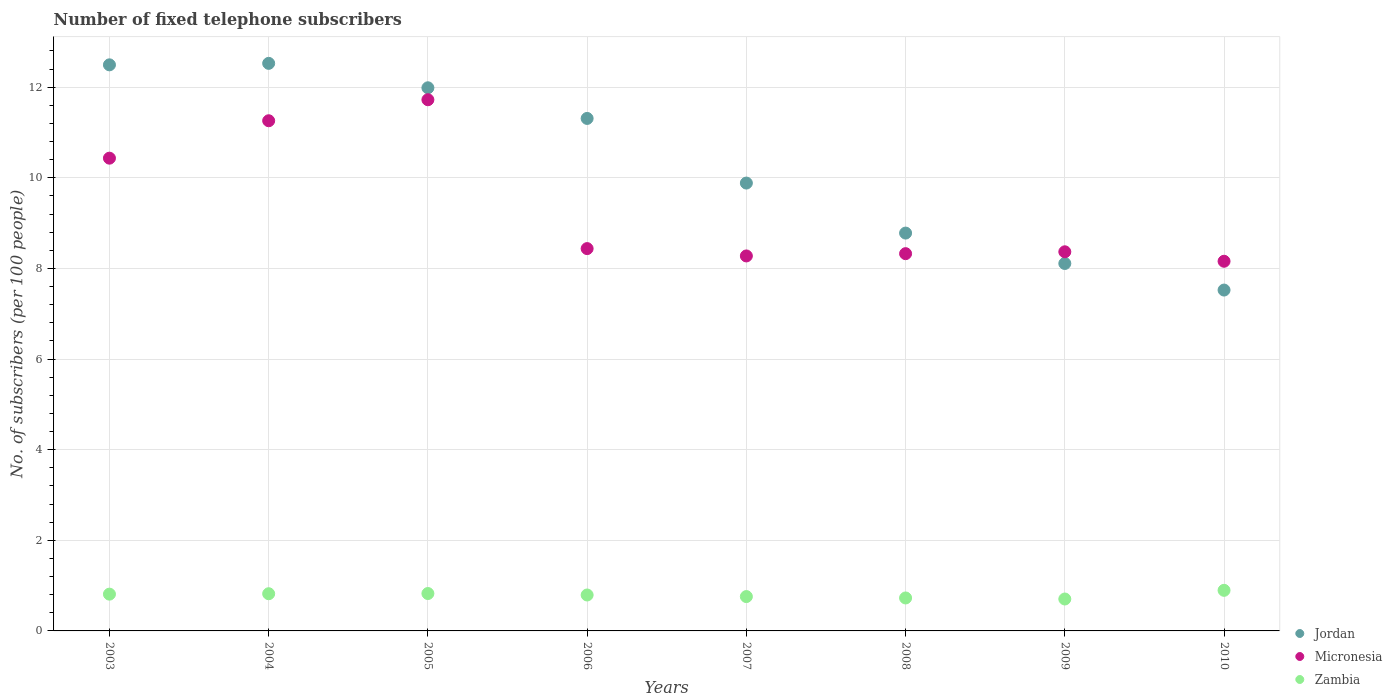What is the number of fixed telephone subscribers in Jordan in 2010?
Provide a short and direct response. 7.52. Across all years, what is the maximum number of fixed telephone subscribers in Micronesia?
Offer a terse response. 11.72. Across all years, what is the minimum number of fixed telephone subscribers in Micronesia?
Your response must be concise. 8.16. In which year was the number of fixed telephone subscribers in Jordan maximum?
Offer a very short reply. 2004. In which year was the number of fixed telephone subscribers in Zambia minimum?
Make the answer very short. 2009. What is the total number of fixed telephone subscribers in Micronesia in the graph?
Keep it short and to the point. 74.98. What is the difference between the number of fixed telephone subscribers in Micronesia in 2004 and that in 2008?
Offer a very short reply. 2.93. What is the difference between the number of fixed telephone subscribers in Jordan in 2007 and the number of fixed telephone subscribers in Zambia in 2008?
Provide a short and direct response. 9.16. What is the average number of fixed telephone subscribers in Jordan per year?
Offer a terse response. 10.33. In the year 2006, what is the difference between the number of fixed telephone subscribers in Jordan and number of fixed telephone subscribers in Zambia?
Your response must be concise. 10.52. In how many years, is the number of fixed telephone subscribers in Zambia greater than 6.8?
Give a very brief answer. 0. What is the ratio of the number of fixed telephone subscribers in Jordan in 2005 to that in 2009?
Offer a very short reply. 1.48. Is the number of fixed telephone subscribers in Jordan in 2003 less than that in 2005?
Give a very brief answer. No. What is the difference between the highest and the second highest number of fixed telephone subscribers in Jordan?
Ensure brevity in your answer.  0.03. What is the difference between the highest and the lowest number of fixed telephone subscribers in Micronesia?
Provide a short and direct response. 3.56. Is the sum of the number of fixed telephone subscribers in Jordan in 2007 and 2008 greater than the maximum number of fixed telephone subscribers in Zambia across all years?
Offer a very short reply. Yes. Is it the case that in every year, the sum of the number of fixed telephone subscribers in Micronesia and number of fixed telephone subscribers in Jordan  is greater than the number of fixed telephone subscribers in Zambia?
Provide a short and direct response. Yes. Is the number of fixed telephone subscribers in Jordan strictly greater than the number of fixed telephone subscribers in Zambia over the years?
Make the answer very short. Yes. Is the number of fixed telephone subscribers in Micronesia strictly less than the number of fixed telephone subscribers in Zambia over the years?
Make the answer very short. No. How many years are there in the graph?
Offer a very short reply. 8. Are the values on the major ticks of Y-axis written in scientific E-notation?
Offer a terse response. No. How many legend labels are there?
Your response must be concise. 3. How are the legend labels stacked?
Give a very brief answer. Vertical. What is the title of the graph?
Offer a terse response. Number of fixed telephone subscribers. What is the label or title of the X-axis?
Make the answer very short. Years. What is the label or title of the Y-axis?
Offer a very short reply. No. of subscribers (per 100 people). What is the No. of subscribers (per 100 people) in Jordan in 2003?
Your answer should be very brief. 12.49. What is the No. of subscribers (per 100 people) of Micronesia in 2003?
Provide a succinct answer. 10.43. What is the No. of subscribers (per 100 people) of Zambia in 2003?
Give a very brief answer. 0.81. What is the No. of subscribers (per 100 people) in Jordan in 2004?
Ensure brevity in your answer.  12.53. What is the No. of subscribers (per 100 people) of Micronesia in 2004?
Give a very brief answer. 11.26. What is the No. of subscribers (per 100 people) in Zambia in 2004?
Ensure brevity in your answer.  0.82. What is the No. of subscribers (per 100 people) of Jordan in 2005?
Your answer should be very brief. 11.99. What is the No. of subscribers (per 100 people) in Micronesia in 2005?
Your response must be concise. 11.72. What is the No. of subscribers (per 100 people) in Zambia in 2005?
Keep it short and to the point. 0.83. What is the No. of subscribers (per 100 people) in Jordan in 2006?
Your answer should be very brief. 11.31. What is the No. of subscribers (per 100 people) of Micronesia in 2006?
Your answer should be compact. 8.44. What is the No. of subscribers (per 100 people) in Zambia in 2006?
Offer a very short reply. 0.79. What is the No. of subscribers (per 100 people) of Jordan in 2007?
Provide a succinct answer. 9.88. What is the No. of subscribers (per 100 people) in Micronesia in 2007?
Provide a succinct answer. 8.28. What is the No. of subscribers (per 100 people) in Zambia in 2007?
Keep it short and to the point. 0.76. What is the No. of subscribers (per 100 people) of Jordan in 2008?
Your answer should be very brief. 8.78. What is the No. of subscribers (per 100 people) in Micronesia in 2008?
Your answer should be compact. 8.33. What is the No. of subscribers (per 100 people) in Zambia in 2008?
Ensure brevity in your answer.  0.73. What is the No. of subscribers (per 100 people) in Jordan in 2009?
Offer a terse response. 8.11. What is the No. of subscribers (per 100 people) of Micronesia in 2009?
Your response must be concise. 8.37. What is the No. of subscribers (per 100 people) of Zambia in 2009?
Keep it short and to the point. 0.7. What is the No. of subscribers (per 100 people) of Jordan in 2010?
Offer a terse response. 7.52. What is the No. of subscribers (per 100 people) of Micronesia in 2010?
Give a very brief answer. 8.16. What is the No. of subscribers (per 100 people) of Zambia in 2010?
Offer a very short reply. 0.9. Across all years, what is the maximum No. of subscribers (per 100 people) of Jordan?
Your response must be concise. 12.53. Across all years, what is the maximum No. of subscribers (per 100 people) in Micronesia?
Provide a short and direct response. 11.72. Across all years, what is the maximum No. of subscribers (per 100 people) of Zambia?
Your response must be concise. 0.9. Across all years, what is the minimum No. of subscribers (per 100 people) of Jordan?
Your answer should be very brief. 7.52. Across all years, what is the minimum No. of subscribers (per 100 people) in Micronesia?
Ensure brevity in your answer.  8.16. Across all years, what is the minimum No. of subscribers (per 100 people) of Zambia?
Make the answer very short. 0.7. What is the total No. of subscribers (per 100 people) in Jordan in the graph?
Your answer should be very brief. 82.61. What is the total No. of subscribers (per 100 people) of Micronesia in the graph?
Provide a succinct answer. 74.98. What is the total No. of subscribers (per 100 people) of Zambia in the graph?
Ensure brevity in your answer.  6.34. What is the difference between the No. of subscribers (per 100 people) in Jordan in 2003 and that in 2004?
Keep it short and to the point. -0.03. What is the difference between the No. of subscribers (per 100 people) in Micronesia in 2003 and that in 2004?
Offer a very short reply. -0.83. What is the difference between the No. of subscribers (per 100 people) of Zambia in 2003 and that in 2004?
Your answer should be compact. -0.01. What is the difference between the No. of subscribers (per 100 people) of Jordan in 2003 and that in 2005?
Give a very brief answer. 0.51. What is the difference between the No. of subscribers (per 100 people) in Micronesia in 2003 and that in 2005?
Your answer should be compact. -1.29. What is the difference between the No. of subscribers (per 100 people) of Zambia in 2003 and that in 2005?
Ensure brevity in your answer.  -0.01. What is the difference between the No. of subscribers (per 100 people) in Jordan in 2003 and that in 2006?
Offer a terse response. 1.18. What is the difference between the No. of subscribers (per 100 people) in Micronesia in 2003 and that in 2006?
Offer a very short reply. 2. What is the difference between the No. of subscribers (per 100 people) of Zambia in 2003 and that in 2006?
Your answer should be compact. 0.02. What is the difference between the No. of subscribers (per 100 people) in Jordan in 2003 and that in 2007?
Your response must be concise. 2.61. What is the difference between the No. of subscribers (per 100 people) in Micronesia in 2003 and that in 2007?
Offer a very short reply. 2.16. What is the difference between the No. of subscribers (per 100 people) in Zambia in 2003 and that in 2007?
Your answer should be compact. 0.05. What is the difference between the No. of subscribers (per 100 people) of Jordan in 2003 and that in 2008?
Provide a succinct answer. 3.71. What is the difference between the No. of subscribers (per 100 people) in Micronesia in 2003 and that in 2008?
Make the answer very short. 2.11. What is the difference between the No. of subscribers (per 100 people) in Zambia in 2003 and that in 2008?
Give a very brief answer. 0.08. What is the difference between the No. of subscribers (per 100 people) in Jordan in 2003 and that in 2009?
Offer a very short reply. 4.38. What is the difference between the No. of subscribers (per 100 people) of Micronesia in 2003 and that in 2009?
Your answer should be compact. 2.07. What is the difference between the No. of subscribers (per 100 people) of Zambia in 2003 and that in 2009?
Your answer should be compact. 0.11. What is the difference between the No. of subscribers (per 100 people) of Jordan in 2003 and that in 2010?
Offer a terse response. 4.97. What is the difference between the No. of subscribers (per 100 people) of Micronesia in 2003 and that in 2010?
Offer a very short reply. 2.28. What is the difference between the No. of subscribers (per 100 people) of Zambia in 2003 and that in 2010?
Provide a short and direct response. -0.08. What is the difference between the No. of subscribers (per 100 people) of Jordan in 2004 and that in 2005?
Your response must be concise. 0.54. What is the difference between the No. of subscribers (per 100 people) in Micronesia in 2004 and that in 2005?
Give a very brief answer. -0.46. What is the difference between the No. of subscribers (per 100 people) in Zambia in 2004 and that in 2005?
Provide a short and direct response. -0. What is the difference between the No. of subscribers (per 100 people) of Jordan in 2004 and that in 2006?
Offer a very short reply. 1.22. What is the difference between the No. of subscribers (per 100 people) in Micronesia in 2004 and that in 2006?
Offer a very short reply. 2.82. What is the difference between the No. of subscribers (per 100 people) of Zambia in 2004 and that in 2006?
Provide a short and direct response. 0.03. What is the difference between the No. of subscribers (per 100 people) in Jordan in 2004 and that in 2007?
Offer a terse response. 2.64. What is the difference between the No. of subscribers (per 100 people) in Micronesia in 2004 and that in 2007?
Ensure brevity in your answer.  2.98. What is the difference between the No. of subscribers (per 100 people) in Zambia in 2004 and that in 2007?
Offer a very short reply. 0.06. What is the difference between the No. of subscribers (per 100 people) in Jordan in 2004 and that in 2008?
Your answer should be compact. 3.75. What is the difference between the No. of subscribers (per 100 people) of Micronesia in 2004 and that in 2008?
Provide a succinct answer. 2.93. What is the difference between the No. of subscribers (per 100 people) of Zambia in 2004 and that in 2008?
Your answer should be compact. 0.09. What is the difference between the No. of subscribers (per 100 people) in Jordan in 2004 and that in 2009?
Your answer should be compact. 4.42. What is the difference between the No. of subscribers (per 100 people) of Micronesia in 2004 and that in 2009?
Provide a short and direct response. 2.89. What is the difference between the No. of subscribers (per 100 people) of Zambia in 2004 and that in 2009?
Give a very brief answer. 0.12. What is the difference between the No. of subscribers (per 100 people) of Jordan in 2004 and that in 2010?
Make the answer very short. 5. What is the difference between the No. of subscribers (per 100 people) of Micronesia in 2004 and that in 2010?
Offer a very short reply. 3.1. What is the difference between the No. of subscribers (per 100 people) in Zambia in 2004 and that in 2010?
Keep it short and to the point. -0.07. What is the difference between the No. of subscribers (per 100 people) of Jordan in 2005 and that in 2006?
Your answer should be very brief. 0.68. What is the difference between the No. of subscribers (per 100 people) in Micronesia in 2005 and that in 2006?
Provide a succinct answer. 3.29. What is the difference between the No. of subscribers (per 100 people) of Zambia in 2005 and that in 2006?
Keep it short and to the point. 0.03. What is the difference between the No. of subscribers (per 100 people) in Jordan in 2005 and that in 2007?
Your response must be concise. 2.1. What is the difference between the No. of subscribers (per 100 people) in Micronesia in 2005 and that in 2007?
Make the answer very short. 3.45. What is the difference between the No. of subscribers (per 100 people) of Zambia in 2005 and that in 2007?
Provide a short and direct response. 0.07. What is the difference between the No. of subscribers (per 100 people) in Jordan in 2005 and that in 2008?
Keep it short and to the point. 3.21. What is the difference between the No. of subscribers (per 100 people) of Micronesia in 2005 and that in 2008?
Your answer should be compact. 3.4. What is the difference between the No. of subscribers (per 100 people) in Zambia in 2005 and that in 2008?
Your answer should be compact. 0.1. What is the difference between the No. of subscribers (per 100 people) of Jordan in 2005 and that in 2009?
Offer a terse response. 3.88. What is the difference between the No. of subscribers (per 100 people) in Micronesia in 2005 and that in 2009?
Offer a terse response. 3.36. What is the difference between the No. of subscribers (per 100 people) of Zambia in 2005 and that in 2009?
Provide a short and direct response. 0.12. What is the difference between the No. of subscribers (per 100 people) in Jordan in 2005 and that in 2010?
Offer a very short reply. 4.46. What is the difference between the No. of subscribers (per 100 people) of Micronesia in 2005 and that in 2010?
Offer a terse response. 3.56. What is the difference between the No. of subscribers (per 100 people) of Zambia in 2005 and that in 2010?
Offer a very short reply. -0.07. What is the difference between the No. of subscribers (per 100 people) of Jordan in 2006 and that in 2007?
Offer a very short reply. 1.43. What is the difference between the No. of subscribers (per 100 people) of Micronesia in 2006 and that in 2007?
Ensure brevity in your answer.  0.16. What is the difference between the No. of subscribers (per 100 people) of Zambia in 2006 and that in 2007?
Your answer should be compact. 0.04. What is the difference between the No. of subscribers (per 100 people) of Jordan in 2006 and that in 2008?
Make the answer very short. 2.53. What is the difference between the No. of subscribers (per 100 people) of Micronesia in 2006 and that in 2008?
Your answer should be very brief. 0.11. What is the difference between the No. of subscribers (per 100 people) in Zambia in 2006 and that in 2008?
Your answer should be compact. 0.07. What is the difference between the No. of subscribers (per 100 people) in Jordan in 2006 and that in 2009?
Your answer should be very brief. 3.2. What is the difference between the No. of subscribers (per 100 people) of Micronesia in 2006 and that in 2009?
Your response must be concise. 0.07. What is the difference between the No. of subscribers (per 100 people) of Zambia in 2006 and that in 2009?
Your answer should be compact. 0.09. What is the difference between the No. of subscribers (per 100 people) in Jordan in 2006 and that in 2010?
Offer a terse response. 3.79. What is the difference between the No. of subscribers (per 100 people) of Micronesia in 2006 and that in 2010?
Give a very brief answer. 0.28. What is the difference between the No. of subscribers (per 100 people) in Zambia in 2006 and that in 2010?
Keep it short and to the point. -0.1. What is the difference between the No. of subscribers (per 100 people) in Jordan in 2007 and that in 2008?
Your response must be concise. 1.1. What is the difference between the No. of subscribers (per 100 people) in Micronesia in 2007 and that in 2008?
Your answer should be very brief. -0.05. What is the difference between the No. of subscribers (per 100 people) in Zambia in 2007 and that in 2008?
Give a very brief answer. 0.03. What is the difference between the No. of subscribers (per 100 people) in Jordan in 2007 and that in 2009?
Offer a terse response. 1.77. What is the difference between the No. of subscribers (per 100 people) in Micronesia in 2007 and that in 2009?
Your answer should be very brief. -0.09. What is the difference between the No. of subscribers (per 100 people) of Zambia in 2007 and that in 2009?
Make the answer very short. 0.05. What is the difference between the No. of subscribers (per 100 people) in Jordan in 2007 and that in 2010?
Your answer should be compact. 2.36. What is the difference between the No. of subscribers (per 100 people) in Micronesia in 2007 and that in 2010?
Give a very brief answer. 0.12. What is the difference between the No. of subscribers (per 100 people) in Zambia in 2007 and that in 2010?
Ensure brevity in your answer.  -0.14. What is the difference between the No. of subscribers (per 100 people) in Jordan in 2008 and that in 2009?
Keep it short and to the point. 0.67. What is the difference between the No. of subscribers (per 100 people) of Micronesia in 2008 and that in 2009?
Keep it short and to the point. -0.04. What is the difference between the No. of subscribers (per 100 people) of Zambia in 2008 and that in 2009?
Provide a succinct answer. 0.02. What is the difference between the No. of subscribers (per 100 people) of Jordan in 2008 and that in 2010?
Give a very brief answer. 1.26. What is the difference between the No. of subscribers (per 100 people) of Micronesia in 2008 and that in 2010?
Make the answer very short. 0.17. What is the difference between the No. of subscribers (per 100 people) in Zambia in 2008 and that in 2010?
Offer a very short reply. -0.17. What is the difference between the No. of subscribers (per 100 people) of Jordan in 2009 and that in 2010?
Make the answer very short. 0.59. What is the difference between the No. of subscribers (per 100 people) in Micronesia in 2009 and that in 2010?
Make the answer very short. 0.21. What is the difference between the No. of subscribers (per 100 people) of Zambia in 2009 and that in 2010?
Ensure brevity in your answer.  -0.19. What is the difference between the No. of subscribers (per 100 people) of Jordan in 2003 and the No. of subscribers (per 100 people) of Micronesia in 2004?
Offer a terse response. 1.23. What is the difference between the No. of subscribers (per 100 people) of Jordan in 2003 and the No. of subscribers (per 100 people) of Zambia in 2004?
Your answer should be very brief. 11.67. What is the difference between the No. of subscribers (per 100 people) in Micronesia in 2003 and the No. of subscribers (per 100 people) in Zambia in 2004?
Your answer should be very brief. 9.61. What is the difference between the No. of subscribers (per 100 people) in Jordan in 2003 and the No. of subscribers (per 100 people) in Micronesia in 2005?
Make the answer very short. 0.77. What is the difference between the No. of subscribers (per 100 people) of Jordan in 2003 and the No. of subscribers (per 100 people) of Zambia in 2005?
Keep it short and to the point. 11.67. What is the difference between the No. of subscribers (per 100 people) in Micronesia in 2003 and the No. of subscribers (per 100 people) in Zambia in 2005?
Provide a short and direct response. 9.61. What is the difference between the No. of subscribers (per 100 people) of Jordan in 2003 and the No. of subscribers (per 100 people) of Micronesia in 2006?
Offer a very short reply. 4.06. What is the difference between the No. of subscribers (per 100 people) in Jordan in 2003 and the No. of subscribers (per 100 people) in Zambia in 2006?
Offer a very short reply. 11.7. What is the difference between the No. of subscribers (per 100 people) in Micronesia in 2003 and the No. of subscribers (per 100 people) in Zambia in 2006?
Your answer should be compact. 9.64. What is the difference between the No. of subscribers (per 100 people) of Jordan in 2003 and the No. of subscribers (per 100 people) of Micronesia in 2007?
Your response must be concise. 4.22. What is the difference between the No. of subscribers (per 100 people) of Jordan in 2003 and the No. of subscribers (per 100 people) of Zambia in 2007?
Offer a terse response. 11.73. What is the difference between the No. of subscribers (per 100 people) in Micronesia in 2003 and the No. of subscribers (per 100 people) in Zambia in 2007?
Give a very brief answer. 9.67. What is the difference between the No. of subscribers (per 100 people) in Jordan in 2003 and the No. of subscribers (per 100 people) in Micronesia in 2008?
Ensure brevity in your answer.  4.17. What is the difference between the No. of subscribers (per 100 people) in Jordan in 2003 and the No. of subscribers (per 100 people) in Zambia in 2008?
Make the answer very short. 11.77. What is the difference between the No. of subscribers (per 100 people) in Micronesia in 2003 and the No. of subscribers (per 100 people) in Zambia in 2008?
Offer a very short reply. 9.71. What is the difference between the No. of subscribers (per 100 people) in Jordan in 2003 and the No. of subscribers (per 100 people) in Micronesia in 2009?
Your answer should be compact. 4.13. What is the difference between the No. of subscribers (per 100 people) of Jordan in 2003 and the No. of subscribers (per 100 people) of Zambia in 2009?
Make the answer very short. 11.79. What is the difference between the No. of subscribers (per 100 people) in Micronesia in 2003 and the No. of subscribers (per 100 people) in Zambia in 2009?
Ensure brevity in your answer.  9.73. What is the difference between the No. of subscribers (per 100 people) of Jordan in 2003 and the No. of subscribers (per 100 people) of Micronesia in 2010?
Provide a succinct answer. 4.33. What is the difference between the No. of subscribers (per 100 people) of Jordan in 2003 and the No. of subscribers (per 100 people) of Zambia in 2010?
Provide a succinct answer. 11.6. What is the difference between the No. of subscribers (per 100 people) of Micronesia in 2003 and the No. of subscribers (per 100 people) of Zambia in 2010?
Your answer should be very brief. 9.54. What is the difference between the No. of subscribers (per 100 people) in Jordan in 2004 and the No. of subscribers (per 100 people) in Micronesia in 2005?
Keep it short and to the point. 0.8. What is the difference between the No. of subscribers (per 100 people) in Micronesia in 2004 and the No. of subscribers (per 100 people) in Zambia in 2005?
Provide a succinct answer. 10.43. What is the difference between the No. of subscribers (per 100 people) of Jordan in 2004 and the No. of subscribers (per 100 people) of Micronesia in 2006?
Provide a short and direct response. 4.09. What is the difference between the No. of subscribers (per 100 people) in Jordan in 2004 and the No. of subscribers (per 100 people) in Zambia in 2006?
Make the answer very short. 11.73. What is the difference between the No. of subscribers (per 100 people) in Micronesia in 2004 and the No. of subscribers (per 100 people) in Zambia in 2006?
Give a very brief answer. 10.47. What is the difference between the No. of subscribers (per 100 people) of Jordan in 2004 and the No. of subscribers (per 100 people) of Micronesia in 2007?
Your answer should be compact. 4.25. What is the difference between the No. of subscribers (per 100 people) of Jordan in 2004 and the No. of subscribers (per 100 people) of Zambia in 2007?
Give a very brief answer. 11.77. What is the difference between the No. of subscribers (per 100 people) in Micronesia in 2004 and the No. of subscribers (per 100 people) in Zambia in 2007?
Your answer should be compact. 10.5. What is the difference between the No. of subscribers (per 100 people) in Jordan in 2004 and the No. of subscribers (per 100 people) in Micronesia in 2008?
Offer a very short reply. 4.2. What is the difference between the No. of subscribers (per 100 people) of Jordan in 2004 and the No. of subscribers (per 100 people) of Zambia in 2008?
Give a very brief answer. 11.8. What is the difference between the No. of subscribers (per 100 people) in Micronesia in 2004 and the No. of subscribers (per 100 people) in Zambia in 2008?
Offer a terse response. 10.53. What is the difference between the No. of subscribers (per 100 people) in Jordan in 2004 and the No. of subscribers (per 100 people) in Micronesia in 2009?
Provide a short and direct response. 4.16. What is the difference between the No. of subscribers (per 100 people) in Jordan in 2004 and the No. of subscribers (per 100 people) in Zambia in 2009?
Provide a succinct answer. 11.82. What is the difference between the No. of subscribers (per 100 people) in Micronesia in 2004 and the No. of subscribers (per 100 people) in Zambia in 2009?
Make the answer very short. 10.55. What is the difference between the No. of subscribers (per 100 people) of Jordan in 2004 and the No. of subscribers (per 100 people) of Micronesia in 2010?
Offer a very short reply. 4.37. What is the difference between the No. of subscribers (per 100 people) of Jordan in 2004 and the No. of subscribers (per 100 people) of Zambia in 2010?
Offer a very short reply. 11.63. What is the difference between the No. of subscribers (per 100 people) in Micronesia in 2004 and the No. of subscribers (per 100 people) in Zambia in 2010?
Your response must be concise. 10.36. What is the difference between the No. of subscribers (per 100 people) in Jordan in 2005 and the No. of subscribers (per 100 people) in Micronesia in 2006?
Keep it short and to the point. 3.55. What is the difference between the No. of subscribers (per 100 people) in Jordan in 2005 and the No. of subscribers (per 100 people) in Zambia in 2006?
Provide a succinct answer. 11.19. What is the difference between the No. of subscribers (per 100 people) in Micronesia in 2005 and the No. of subscribers (per 100 people) in Zambia in 2006?
Provide a short and direct response. 10.93. What is the difference between the No. of subscribers (per 100 people) of Jordan in 2005 and the No. of subscribers (per 100 people) of Micronesia in 2007?
Give a very brief answer. 3.71. What is the difference between the No. of subscribers (per 100 people) in Jordan in 2005 and the No. of subscribers (per 100 people) in Zambia in 2007?
Offer a very short reply. 11.23. What is the difference between the No. of subscribers (per 100 people) of Micronesia in 2005 and the No. of subscribers (per 100 people) of Zambia in 2007?
Give a very brief answer. 10.96. What is the difference between the No. of subscribers (per 100 people) in Jordan in 2005 and the No. of subscribers (per 100 people) in Micronesia in 2008?
Offer a terse response. 3.66. What is the difference between the No. of subscribers (per 100 people) of Jordan in 2005 and the No. of subscribers (per 100 people) of Zambia in 2008?
Ensure brevity in your answer.  11.26. What is the difference between the No. of subscribers (per 100 people) in Micronesia in 2005 and the No. of subscribers (per 100 people) in Zambia in 2008?
Provide a short and direct response. 11. What is the difference between the No. of subscribers (per 100 people) in Jordan in 2005 and the No. of subscribers (per 100 people) in Micronesia in 2009?
Keep it short and to the point. 3.62. What is the difference between the No. of subscribers (per 100 people) of Jordan in 2005 and the No. of subscribers (per 100 people) of Zambia in 2009?
Provide a short and direct response. 11.28. What is the difference between the No. of subscribers (per 100 people) in Micronesia in 2005 and the No. of subscribers (per 100 people) in Zambia in 2009?
Offer a terse response. 11.02. What is the difference between the No. of subscribers (per 100 people) in Jordan in 2005 and the No. of subscribers (per 100 people) in Micronesia in 2010?
Your answer should be compact. 3.83. What is the difference between the No. of subscribers (per 100 people) in Jordan in 2005 and the No. of subscribers (per 100 people) in Zambia in 2010?
Offer a terse response. 11.09. What is the difference between the No. of subscribers (per 100 people) of Micronesia in 2005 and the No. of subscribers (per 100 people) of Zambia in 2010?
Offer a very short reply. 10.83. What is the difference between the No. of subscribers (per 100 people) of Jordan in 2006 and the No. of subscribers (per 100 people) of Micronesia in 2007?
Keep it short and to the point. 3.03. What is the difference between the No. of subscribers (per 100 people) in Jordan in 2006 and the No. of subscribers (per 100 people) in Zambia in 2007?
Ensure brevity in your answer.  10.55. What is the difference between the No. of subscribers (per 100 people) of Micronesia in 2006 and the No. of subscribers (per 100 people) of Zambia in 2007?
Give a very brief answer. 7.68. What is the difference between the No. of subscribers (per 100 people) in Jordan in 2006 and the No. of subscribers (per 100 people) in Micronesia in 2008?
Provide a short and direct response. 2.98. What is the difference between the No. of subscribers (per 100 people) of Jordan in 2006 and the No. of subscribers (per 100 people) of Zambia in 2008?
Make the answer very short. 10.58. What is the difference between the No. of subscribers (per 100 people) of Micronesia in 2006 and the No. of subscribers (per 100 people) of Zambia in 2008?
Give a very brief answer. 7.71. What is the difference between the No. of subscribers (per 100 people) of Jordan in 2006 and the No. of subscribers (per 100 people) of Micronesia in 2009?
Your answer should be compact. 2.94. What is the difference between the No. of subscribers (per 100 people) of Jordan in 2006 and the No. of subscribers (per 100 people) of Zambia in 2009?
Offer a very short reply. 10.61. What is the difference between the No. of subscribers (per 100 people) in Micronesia in 2006 and the No. of subscribers (per 100 people) in Zambia in 2009?
Offer a terse response. 7.73. What is the difference between the No. of subscribers (per 100 people) in Jordan in 2006 and the No. of subscribers (per 100 people) in Micronesia in 2010?
Give a very brief answer. 3.15. What is the difference between the No. of subscribers (per 100 people) in Jordan in 2006 and the No. of subscribers (per 100 people) in Zambia in 2010?
Offer a terse response. 10.41. What is the difference between the No. of subscribers (per 100 people) in Micronesia in 2006 and the No. of subscribers (per 100 people) in Zambia in 2010?
Your answer should be compact. 7.54. What is the difference between the No. of subscribers (per 100 people) in Jordan in 2007 and the No. of subscribers (per 100 people) in Micronesia in 2008?
Offer a terse response. 1.56. What is the difference between the No. of subscribers (per 100 people) of Jordan in 2007 and the No. of subscribers (per 100 people) of Zambia in 2008?
Provide a short and direct response. 9.16. What is the difference between the No. of subscribers (per 100 people) of Micronesia in 2007 and the No. of subscribers (per 100 people) of Zambia in 2008?
Provide a succinct answer. 7.55. What is the difference between the No. of subscribers (per 100 people) of Jordan in 2007 and the No. of subscribers (per 100 people) of Micronesia in 2009?
Make the answer very short. 1.52. What is the difference between the No. of subscribers (per 100 people) of Jordan in 2007 and the No. of subscribers (per 100 people) of Zambia in 2009?
Your response must be concise. 9.18. What is the difference between the No. of subscribers (per 100 people) in Micronesia in 2007 and the No. of subscribers (per 100 people) in Zambia in 2009?
Keep it short and to the point. 7.57. What is the difference between the No. of subscribers (per 100 people) of Jordan in 2007 and the No. of subscribers (per 100 people) of Micronesia in 2010?
Your answer should be very brief. 1.73. What is the difference between the No. of subscribers (per 100 people) of Jordan in 2007 and the No. of subscribers (per 100 people) of Zambia in 2010?
Offer a very short reply. 8.99. What is the difference between the No. of subscribers (per 100 people) of Micronesia in 2007 and the No. of subscribers (per 100 people) of Zambia in 2010?
Ensure brevity in your answer.  7.38. What is the difference between the No. of subscribers (per 100 people) of Jordan in 2008 and the No. of subscribers (per 100 people) of Micronesia in 2009?
Provide a short and direct response. 0.41. What is the difference between the No. of subscribers (per 100 people) of Jordan in 2008 and the No. of subscribers (per 100 people) of Zambia in 2009?
Provide a succinct answer. 8.08. What is the difference between the No. of subscribers (per 100 people) in Micronesia in 2008 and the No. of subscribers (per 100 people) in Zambia in 2009?
Offer a very short reply. 7.62. What is the difference between the No. of subscribers (per 100 people) of Jordan in 2008 and the No. of subscribers (per 100 people) of Micronesia in 2010?
Give a very brief answer. 0.62. What is the difference between the No. of subscribers (per 100 people) in Jordan in 2008 and the No. of subscribers (per 100 people) in Zambia in 2010?
Your response must be concise. 7.88. What is the difference between the No. of subscribers (per 100 people) of Micronesia in 2008 and the No. of subscribers (per 100 people) of Zambia in 2010?
Provide a short and direct response. 7.43. What is the difference between the No. of subscribers (per 100 people) in Jordan in 2009 and the No. of subscribers (per 100 people) in Micronesia in 2010?
Offer a very short reply. -0.05. What is the difference between the No. of subscribers (per 100 people) of Jordan in 2009 and the No. of subscribers (per 100 people) of Zambia in 2010?
Your answer should be compact. 7.21. What is the difference between the No. of subscribers (per 100 people) of Micronesia in 2009 and the No. of subscribers (per 100 people) of Zambia in 2010?
Keep it short and to the point. 7.47. What is the average No. of subscribers (per 100 people) in Jordan per year?
Keep it short and to the point. 10.33. What is the average No. of subscribers (per 100 people) in Micronesia per year?
Provide a short and direct response. 9.37. What is the average No. of subscribers (per 100 people) of Zambia per year?
Provide a succinct answer. 0.79. In the year 2003, what is the difference between the No. of subscribers (per 100 people) in Jordan and No. of subscribers (per 100 people) in Micronesia?
Your answer should be compact. 2.06. In the year 2003, what is the difference between the No. of subscribers (per 100 people) of Jordan and No. of subscribers (per 100 people) of Zambia?
Offer a very short reply. 11.68. In the year 2003, what is the difference between the No. of subscribers (per 100 people) of Micronesia and No. of subscribers (per 100 people) of Zambia?
Offer a very short reply. 9.62. In the year 2004, what is the difference between the No. of subscribers (per 100 people) of Jordan and No. of subscribers (per 100 people) of Micronesia?
Ensure brevity in your answer.  1.27. In the year 2004, what is the difference between the No. of subscribers (per 100 people) of Jordan and No. of subscribers (per 100 people) of Zambia?
Give a very brief answer. 11.7. In the year 2004, what is the difference between the No. of subscribers (per 100 people) of Micronesia and No. of subscribers (per 100 people) of Zambia?
Provide a short and direct response. 10.44. In the year 2005, what is the difference between the No. of subscribers (per 100 people) in Jordan and No. of subscribers (per 100 people) in Micronesia?
Offer a terse response. 0.26. In the year 2005, what is the difference between the No. of subscribers (per 100 people) in Jordan and No. of subscribers (per 100 people) in Zambia?
Provide a succinct answer. 11.16. In the year 2005, what is the difference between the No. of subscribers (per 100 people) of Micronesia and No. of subscribers (per 100 people) of Zambia?
Your response must be concise. 10.9. In the year 2006, what is the difference between the No. of subscribers (per 100 people) in Jordan and No. of subscribers (per 100 people) in Micronesia?
Give a very brief answer. 2.87. In the year 2006, what is the difference between the No. of subscribers (per 100 people) in Jordan and No. of subscribers (per 100 people) in Zambia?
Your answer should be very brief. 10.52. In the year 2006, what is the difference between the No. of subscribers (per 100 people) of Micronesia and No. of subscribers (per 100 people) of Zambia?
Offer a very short reply. 7.64. In the year 2007, what is the difference between the No. of subscribers (per 100 people) of Jordan and No. of subscribers (per 100 people) of Micronesia?
Make the answer very short. 1.61. In the year 2007, what is the difference between the No. of subscribers (per 100 people) of Jordan and No. of subscribers (per 100 people) of Zambia?
Offer a terse response. 9.13. In the year 2007, what is the difference between the No. of subscribers (per 100 people) in Micronesia and No. of subscribers (per 100 people) in Zambia?
Provide a succinct answer. 7.52. In the year 2008, what is the difference between the No. of subscribers (per 100 people) in Jordan and No. of subscribers (per 100 people) in Micronesia?
Your answer should be very brief. 0.45. In the year 2008, what is the difference between the No. of subscribers (per 100 people) of Jordan and No. of subscribers (per 100 people) of Zambia?
Give a very brief answer. 8.05. In the year 2008, what is the difference between the No. of subscribers (per 100 people) in Micronesia and No. of subscribers (per 100 people) in Zambia?
Give a very brief answer. 7.6. In the year 2009, what is the difference between the No. of subscribers (per 100 people) of Jordan and No. of subscribers (per 100 people) of Micronesia?
Provide a short and direct response. -0.26. In the year 2009, what is the difference between the No. of subscribers (per 100 people) of Jordan and No. of subscribers (per 100 people) of Zambia?
Your answer should be compact. 7.4. In the year 2009, what is the difference between the No. of subscribers (per 100 people) of Micronesia and No. of subscribers (per 100 people) of Zambia?
Keep it short and to the point. 7.66. In the year 2010, what is the difference between the No. of subscribers (per 100 people) of Jordan and No. of subscribers (per 100 people) of Micronesia?
Your response must be concise. -0.64. In the year 2010, what is the difference between the No. of subscribers (per 100 people) in Jordan and No. of subscribers (per 100 people) in Zambia?
Your answer should be compact. 6.63. In the year 2010, what is the difference between the No. of subscribers (per 100 people) in Micronesia and No. of subscribers (per 100 people) in Zambia?
Your answer should be very brief. 7.26. What is the ratio of the No. of subscribers (per 100 people) of Jordan in 2003 to that in 2004?
Provide a short and direct response. 1. What is the ratio of the No. of subscribers (per 100 people) of Micronesia in 2003 to that in 2004?
Make the answer very short. 0.93. What is the ratio of the No. of subscribers (per 100 people) in Zambia in 2003 to that in 2004?
Offer a very short reply. 0.99. What is the ratio of the No. of subscribers (per 100 people) in Jordan in 2003 to that in 2005?
Offer a very short reply. 1.04. What is the ratio of the No. of subscribers (per 100 people) of Micronesia in 2003 to that in 2005?
Make the answer very short. 0.89. What is the ratio of the No. of subscribers (per 100 people) of Zambia in 2003 to that in 2005?
Give a very brief answer. 0.98. What is the ratio of the No. of subscribers (per 100 people) of Jordan in 2003 to that in 2006?
Your response must be concise. 1.1. What is the ratio of the No. of subscribers (per 100 people) of Micronesia in 2003 to that in 2006?
Your answer should be compact. 1.24. What is the ratio of the No. of subscribers (per 100 people) in Zambia in 2003 to that in 2006?
Your answer should be very brief. 1.02. What is the ratio of the No. of subscribers (per 100 people) in Jordan in 2003 to that in 2007?
Keep it short and to the point. 1.26. What is the ratio of the No. of subscribers (per 100 people) of Micronesia in 2003 to that in 2007?
Your response must be concise. 1.26. What is the ratio of the No. of subscribers (per 100 people) of Zambia in 2003 to that in 2007?
Offer a very short reply. 1.07. What is the ratio of the No. of subscribers (per 100 people) in Jordan in 2003 to that in 2008?
Make the answer very short. 1.42. What is the ratio of the No. of subscribers (per 100 people) of Micronesia in 2003 to that in 2008?
Give a very brief answer. 1.25. What is the ratio of the No. of subscribers (per 100 people) of Zambia in 2003 to that in 2008?
Make the answer very short. 1.12. What is the ratio of the No. of subscribers (per 100 people) of Jordan in 2003 to that in 2009?
Provide a succinct answer. 1.54. What is the ratio of the No. of subscribers (per 100 people) in Micronesia in 2003 to that in 2009?
Ensure brevity in your answer.  1.25. What is the ratio of the No. of subscribers (per 100 people) of Zambia in 2003 to that in 2009?
Offer a very short reply. 1.15. What is the ratio of the No. of subscribers (per 100 people) in Jordan in 2003 to that in 2010?
Ensure brevity in your answer.  1.66. What is the ratio of the No. of subscribers (per 100 people) in Micronesia in 2003 to that in 2010?
Offer a very short reply. 1.28. What is the ratio of the No. of subscribers (per 100 people) in Zambia in 2003 to that in 2010?
Make the answer very short. 0.91. What is the ratio of the No. of subscribers (per 100 people) in Jordan in 2004 to that in 2005?
Offer a terse response. 1.04. What is the ratio of the No. of subscribers (per 100 people) of Micronesia in 2004 to that in 2005?
Offer a terse response. 0.96. What is the ratio of the No. of subscribers (per 100 people) in Jordan in 2004 to that in 2006?
Offer a terse response. 1.11. What is the ratio of the No. of subscribers (per 100 people) of Micronesia in 2004 to that in 2006?
Make the answer very short. 1.33. What is the ratio of the No. of subscribers (per 100 people) of Zambia in 2004 to that in 2006?
Your answer should be compact. 1.03. What is the ratio of the No. of subscribers (per 100 people) in Jordan in 2004 to that in 2007?
Your response must be concise. 1.27. What is the ratio of the No. of subscribers (per 100 people) in Micronesia in 2004 to that in 2007?
Offer a very short reply. 1.36. What is the ratio of the No. of subscribers (per 100 people) in Zambia in 2004 to that in 2007?
Make the answer very short. 1.08. What is the ratio of the No. of subscribers (per 100 people) in Jordan in 2004 to that in 2008?
Make the answer very short. 1.43. What is the ratio of the No. of subscribers (per 100 people) of Micronesia in 2004 to that in 2008?
Your answer should be very brief. 1.35. What is the ratio of the No. of subscribers (per 100 people) of Zambia in 2004 to that in 2008?
Your answer should be very brief. 1.13. What is the ratio of the No. of subscribers (per 100 people) in Jordan in 2004 to that in 2009?
Ensure brevity in your answer.  1.54. What is the ratio of the No. of subscribers (per 100 people) of Micronesia in 2004 to that in 2009?
Ensure brevity in your answer.  1.35. What is the ratio of the No. of subscribers (per 100 people) in Zambia in 2004 to that in 2009?
Your response must be concise. 1.17. What is the ratio of the No. of subscribers (per 100 people) in Jordan in 2004 to that in 2010?
Give a very brief answer. 1.67. What is the ratio of the No. of subscribers (per 100 people) of Micronesia in 2004 to that in 2010?
Offer a terse response. 1.38. What is the ratio of the No. of subscribers (per 100 people) of Zambia in 2004 to that in 2010?
Ensure brevity in your answer.  0.92. What is the ratio of the No. of subscribers (per 100 people) in Jordan in 2005 to that in 2006?
Your answer should be very brief. 1.06. What is the ratio of the No. of subscribers (per 100 people) of Micronesia in 2005 to that in 2006?
Your answer should be very brief. 1.39. What is the ratio of the No. of subscribers (per 100 people) in Zambia in 2005 to that in 2006?
Your answer should be very brief. 1.04. What is the ratio of the No. of subscribers (per 100 people) in Jordan in 2005 to that in 2007?
Give a very brief answer. 1.21. What is the ratio of the No. of subscribers (per 100 people) of Micronesia in 2005 to that in 2007?
Your answer should be very brief. 1.42. What is the ratio of the No. of subscribers (per 100 people) of Zambia in 2005 to that in 2007?
Provide a succinct answer. 1.09. What is the ratio of the No. of subscribers (per 100 people) of Jordan in 2005 to that in 2008?
Provide a succinct answer. 1.37. What is the ratio of the No. of subscribers (per 100 people) of Micronesia in 2005 to that in 2008?
Offer a very short reply. 1.41. What is the ratio of the No. of subscribers (per 100 people) in Zambia in 2005 to that in 2008?
Provide a short and direct response. 1.13. What is the ratio of the No. of subscribers (per 100 people) in Jordan in 2005 to that in 2009?
Make the answer very short. 1.48. What is the ratio of the No. of subscribers (per 100 people) of Micronesia in 2005 to that in 2009?
Keep it short and to the point. 1.4. What is the ratio of the No. of subscribers (per 100 people) in Zambia in 2005 to that in 2009?
Keep it short and to the point. 1.17. What is the ratio of the No. of subscribers (per 100 people) of Jordan in 2005 to that in 2010?
Your answer should be very brief. 1.59. What is the ratio of the No. of subscribers (per 100 people) of Micronesia in 2005 to that in 2010?
Provide a short and direct response. 1.44. What is the ratio of the No. of subscribers (per 100 people) in Zambia in 2005 to that in 2010?
Offer a very short reply. 0.92. What is the ratio of the No. of subscribers (per 100 people) of Jordan in 2006 to that in 2007?
Your response must be concise. 1.14. What is the ratio of the No. of subscribers (per 100 people) in Micronesia in 2006 to that in 2007?
Ensure brevity in your answer.  1.02. What is the ratio of the No. of subscribers (per 100 people) of Zambia in 2006 to that in 2007?
Keep it short and to the point. 1.05. What is the ratio of the No. of subscribers (per 100 people) of Jordan in 2006 to that in 2008?
Provide a succinct answer. 1.29. What is the ratio of the No. of subscribers (per 100 people) of Micronesia in 2006 to that in 2008?
Provide a succinct answer. 1.01. What is the ratio of the No. of subscribers (per 100 people) of Zambia in 2006 to that in 2008?
Offer a terse response. 1.09. What is the ratio of the No. of subscribers (per 100 people) in Jordan in 2006 to that in 2009?
Your answer should be very brief. 1.39. What is the ratio of the No. of subscribers (per 100 people) of Micronesia in 2006 to that in 2009?
Keep it short and to the point. 1.01. What is the ratio of the No. of subscribers (per 100 people) in Zambia in 2006 to that in 2009?
Your answer should be compact. 1.13. What is the ratio of the No. of subscribers (per 100 people) in Jordan in 2006 to that in 2010?
Provide a succinct answer. 1.5. What is the ratio of the No. of subscribers (per 100 people) of Micronesia in 2006 to that in 2010?
Give a very brief answer. 1.03. What is the ratio of the No. of subscribers (per 100 people) of Zambia in 2006 to that in 2010?
Offer a very short reply. 0.89. What is the ratio of the No. of subscribers (per 100 people) of Jordan in 2007 to that in 2008?
Provide a succinct answer. 1.13. What is the ratio of the No. of subscribers (per 100 people) in Zambia in 2007 to that in 2008?
Ensure brevity in your answer.  1.04. What is the ratio of the No. of subscribers (per 100 people) in Jordan in 2007 to that in 2009?
Make the answer very short. 1.22. What is the ratio of the No. of subscribers (per 100 people) of Zambia in 2007 to that in 2009?
Your answer should be compact. 1.08. What is the ratio of the No. of subscribers (per 100 people) in Jordan in 2007 to that in 2010?
Give a very brief answer. 1.31. What is the ratio of the No. of subscribers (per 100 people) of Micronesia in 2007 to that in 2010?
Your answer should be very brief. 1.01. What is the ratio of the No. of subscribers (per 100 people) in Zambia in 2007 to that in 2010?
Your answer should be very brief. 0.85. What is the ratio of the No. of subscribers (per 100 people) in Jordan in 2008 to that in 2009?
Ensure brevity in your answer.  1.08. What is the ratio of the No. of subscribers (per 100 people) of Zambia in 2008 to that in 2009?
Ensure brevity in your answer.  1.03. What is the ratio of the No. of subscribers (per 100 people) in Jordan in 2008 to that in 2010?
Offer a very short reply. 1.17. What is the ratio of the No. of subscribers (per 100 people) of Micronesia in 2008 to that in 2010?
Keep it short and to the point. 1.02. What is the ratio of the No. of subscribers (per 100 people) of Zambia in 2008 to that in 2010?
Your response must be concise. 0.81. What is the ratio of the No. of subscribers (per 100 people) of Jordan in 2009 to that in 2010?
Give a very brief answer. 1.08. What is the ratio of the No. of subscribers (per 100 people) in Micronesia in 2009 to that in 2010?
Provide a short and direct response. 1.03. What is the ratio of the No. of subscribers (per 100 people) in Zambia in 2009 to that in 2010?
Your response must be concise. 0.79. What is the difference between the highest and the second highest No. of subscribers (per 100 people) of Jordan?
Your answer should be very brief. 0.03. What is the difference between the highest and the second highest No. of subscribers (per 100 people) in Micronesia?
Provide a short and direct response. 0.46. What is the difference between the highest and the second highest No. of subscribers (per 100 people) of Zambia?
Make the answer very short. 0.07. What is the difference between the highest and the lowest No. of subscribers (per 100 people) in Jordan?
Your response must be concise. 5. What is the difference between the highest and the lowest No. of subscribers (per 100 people) in Micronesia?
Keep it short and to the point. 3.56. What is the difference between the highest and the lowest No. of subscribers (per 100 people) of Zambia?
Your answer should be compact. 0.19. 